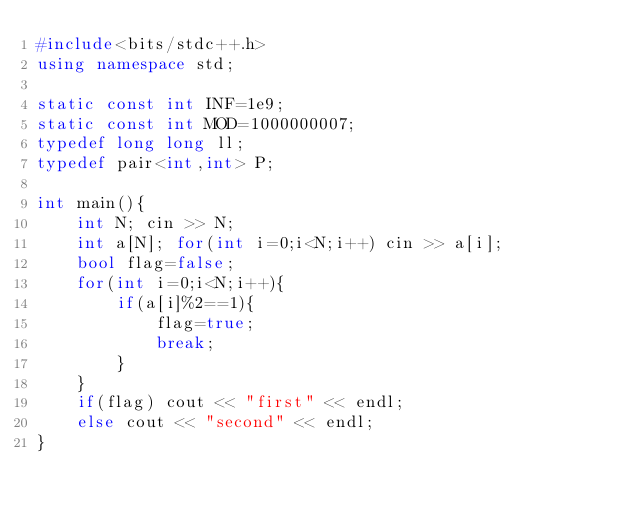Convert code to text. <code><loc_0><loc_0><loc_500><loc_500><_C++_>#include<bits/stdc++.h>
using namespace std;

static const int INF=1e9;
static const int MOD=1000000007;
typedef long long ll;
typedef pair<int,int> P;

int main(){
    int N; cin >> N;
    int a[N]; for(int i=0;i<N;i++) cin >> a[i];
    bool flag=false;
    for(int i=0;i<N;i++){
        if(a[i]%2==1){
            flag=true;
            break;
        }
    }
    if(flag) cout << "first" << endl;
    else cout << "second" << endl;
}
</code> 